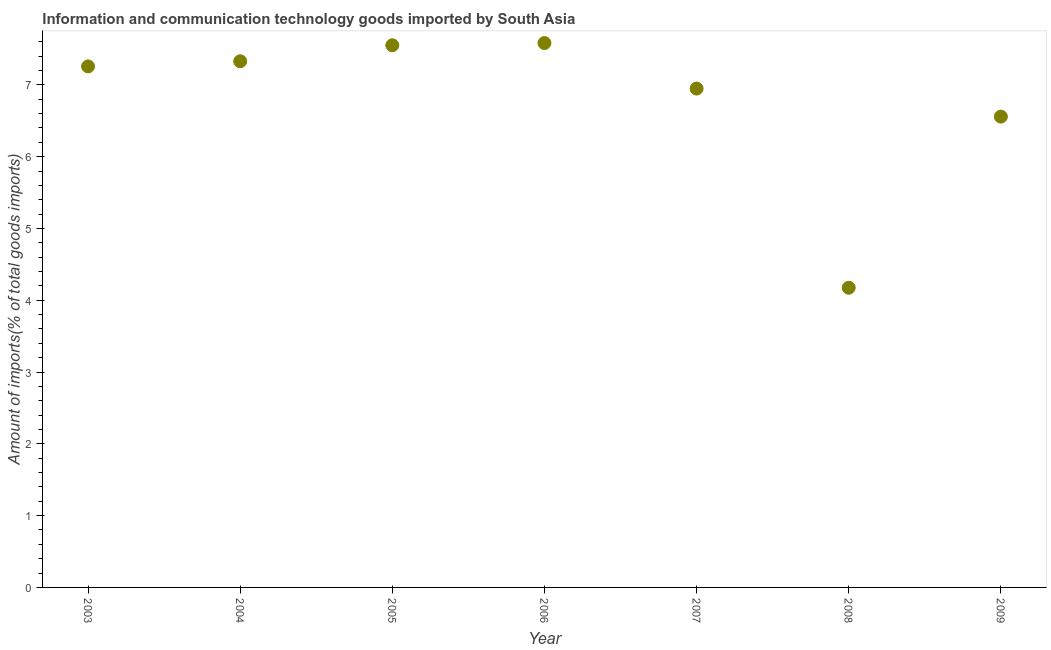What is the amount of ict goods imports in 2004?
Provide a short and direct response. 7.33. Across all years, what is the maximum amount of ict goods imports?
Your response must be concise. 7.58. Across all years, what is the minimum amount of ict goods imports?
Your answer should be very brief. 4.17. In which year was the amount of ict goods imports minimum?
Keep it short and to the point. 2008. What is the sum of the amount of ict goods imports?
Your response must be concise. 47.4. What is the difference between the amount of ict goods imports in 2007 and 2008?
Ensure brevity in your answer.  2.77. What is the average amount of ict goods imports per year?
Your response must be concise. 6.77. What is the median amount of ict goods imports?
Ensure brevity in your answer.  7.26. Do a majority of the years between 2009 and 2008 (inclusive) have amount of ict goods imports greater than 3.6 %?
Your answer should be compact. No. What is the ratio of the amount of ict goods imports in 2006 to that in 2009?
Provide a short and direct response. 1.16. Is the amount of ict goods imports in 2004 less than that in 2005?
Provide a short and direct response. Yes. Is the difference between the amount of ict goods imports in 2008 and 2009 greater than the difference between any two years?
Offer a very short reply. No. What is the difference between the highest and the second highest amount of ict goods imports?
Your response must be concise. 0.03. Is the sum of the amount of ict goods imports in 2007 and 2008 greater than the maximum amount of ict goods imports across all years?
Keep it short and to the point. Yes. What is the difference between the highest and the lowest amount of ict goods imports?
Keep it short and to the point. 3.41. Does the amount of ict goods imports monotonically increase over the years?
Your response must be concise. No. How many dotlines are there?
Offer a very short reply. 1. What is the difference between two consecutive major ticks on the Y-axis?
Provide a succinct answer. 1. Does the graph contain any zero values?
Your answer should be compact. No. Does the graph contain grids?
Keep it short and to the point. No. What is the title of the graph?
Make the answer very short. Information and communication technology goods imported by South Asia. What is the label or title of the Y-axis?
Your answer should be compact. Amount of imports(% of total goods imports). What is the Amount of imports(% of total goods imports) in 2003?
Offer a terse response. 7.26. What is the Amount of imports(% of total goods imports) in 2004?
Offer a terse response. 7.33. What is the Amount of imports(% of total goods imports) in 2005?
Your answer should be very brief. 7.55. What is the Amount of imports(% of total goods imports) in 2006?
Give a very brief answer. 7.58. What is the Amount of imports(% of total goods imports) in 2007?
Offer a very short reply. 6.95. What is the Amount of imports(% of total goods imports) in 2008?
Offer a terse response. 4.17. What is the Amount of imports(% of total goods imports) in 2009?
Your answer should be very brief. 6.56. What is the difference between the Amount of imports(% of total goods imports) in 2003 and 2004?
Ensure brevity in your answer.  -0.07. What is the difference between the Amount of imports(% of total goods imports) in 2003 and 2005?
Ensure brevity in your answer.  -0.29. What is the difference between the Amount of imports(% of total goods imports) in 2003 and 2006?
Provide a succinct answer. -0.33. What is the difference between the Amount of imports(% of total goods imports) in 2003 and 2007?
Make the answer very short. 0.31. What is the difference between the Amount of imports(% of total goods imports) in 2003 and 2008?
Your answer should be very brief. 3.08. What is the difference between the Amount of imports(% of total goods imports) in 2003 and 2009?
Your answer should be very brief. 0.7. What is the difference between the Amount of imports(% of total goods imports) in 2004 and 2005?
Ensure brevity in your answer.  -0.22. What is the difference between the Amount of imports(% of total goods imports) in 2004 and 2006?
Your response must be concise. -0.25. What is the difference between the Amount of imports(% of total goods imports) in 2004 and 2007?
Your answer should be very brief. 0.38. What is the difference between the Amount of imports(% of total goods imports) in 2004 and 2008?
Your response must be concise. 3.15. What is the difference between the Amount of imports(% of total goods imports) in 2004 and 2009?
Provide a short and direct response. 0.77. What is the difference between the Amount of imports(% of total goods imports) in 2005 and 2006?
Make the answer very short. -0.03. What is the difference between the Amount of imports(% of total goods imports) in 2005 and 2007?
Your response must be concise. 0.6. What is the difference between the Amount of imports(% of total goods imports) in 2005 and 2008?
Offer a very short reply. 3.38. What is the difference between the Amount of imports(% of total goods imports) in 2005 and 2009?
Offer a terse response. 0.99. What is the difference between the Amount of imports(% of total goods imports) in 2006 and 2007?
Offer a terse response. 0.63. What is the difference between the Amount of imports(% of total goods imports) in 2006 and 2008?
Offer a terse response. 3.41. What is the difference between the Amount of imports(% of total goods imports) in 2006 and 2009?
Your answer should be compact. 1.02. What is the difference between the Amount of imports(% of total goods imports) in 2007 and 2008?
Your answer should be compact. 2.77. What is the difference between the Amount of imports(% of total goods imports) in 2007 and 2009?
Provide a short and direct response. 0.39. What is the difference between the Amount of imports(% of total goods imports) in 2008 and 2009?
Provide a short and direct response. -2.38. What is the ratio of the Amount of imports(% of total goods imports) in 2003 to that in 2004?
Ensure brevity in your answer.  0.99. What is the ratio of the Amount of imports(% of total goods imports) in 2003 to that in 2006?
Offer a terse response. 0.96. What is the ratio of the Amount of imports(% of total goods imports) in 2003 to that in 2007?
Ensure brevity in your answer.  1.04. What is the ratio of the Amount of imports(% of total goods imports) in 2003 to that in 2008?
Your answer should be compact. 1.74. What is the ratio of the Amount of imports(% of total goods imports) in 2003 to that in 2009?
Give a very brief answer. 1.11. What is the ratio of the Amount of imports(% of total goods imports) in 2004 to that in 2005?
Ensure brevity in your answer.  0.97. What is the ratio of the Amount of imports(% of total goods imports) in 2004 to that in 2007?
Offer a terse response. 1.05. What is the ratio of the Amount of imports(% of total goods imports) in 2004 to that in 2008?
Your response must be concise. 1.76. What is the ratio of the Amount of imports(% of total goods imports) in 2004 to that in 2009?
Keep it short and to the point. 1.12. What is the ratio of the Amount of imports(% of total goods imports) in 2005 to that in 2006?
Your response must be concise. 1. What is the ratio of the Amount of imports(% of total goods imports) in 2005 to that in 2007?
Ensure brevity in your answer.  1.09. What is the ratio of the Amount of imports(% of total goods imports) in 2005 to that in 2008?
Offer a terse response. 1.81. What is the ratio of the Amount of imports(% of total goods imports) in 2005 to that in 2009?
Offer a terse response. 1.15. What is the ratio of the Amount of imports(% of total goods imports) in 2006 to that in 2007?
Offer a very short reply. 1.09. What is the ratio of the Amount of imports(% of total goods imports) in 2006 to that in 2008?
Provide a succinct answer. 1.82. What is the ratio of the Amount of imports(% of total goods imports) in 2006 to that in 2009?
Offer a terse response. 1.16. What is the ratio of the Amount of imports(% of total goods imports) in 2007 to that in 2008?
Keep it short and to the point. 1.67. What is the ratio of the Amount of imports(% of total goods imports) in 2007 to that in 2009?
Give a very brief answer. 1.06. What is the ratio of the Amount of imports(% of total goods imports) in 2008 to that in 2009?
Offer a terse response. 0.64. 